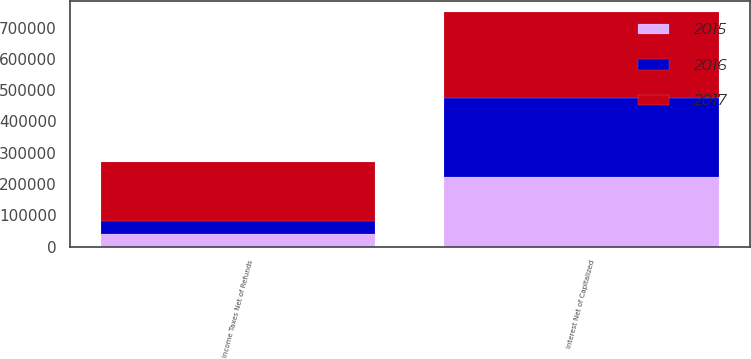Convert chart to OTSL. <chart><loc_0><loc_0><loc_500><loc_500><stacked_bar_chart><ecel><fcel>Interest Net of Capitalized<fcel>Income Taxes Net of Refunds<nl><fcel>2017<fcel>275305<fcel>188946<nl><fcel>2016<fcel>252030<fcel>39293<nl><fcel>2015<fcel>222088<fcel>41108<nl></chart> 